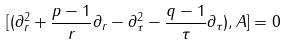Convert formula to latex. <formula><loc_0><loc_0><loc_500><loc_500>[ ( \partial _ { r } ^ { 2 } + \frac { p - 1 } { r } \partial _ { r } - \partial _ { \tau } ^ { 2 } - \frac { q - 1 } { \tau } \partial _ { \tau } ) , A ] = 0</formula> 